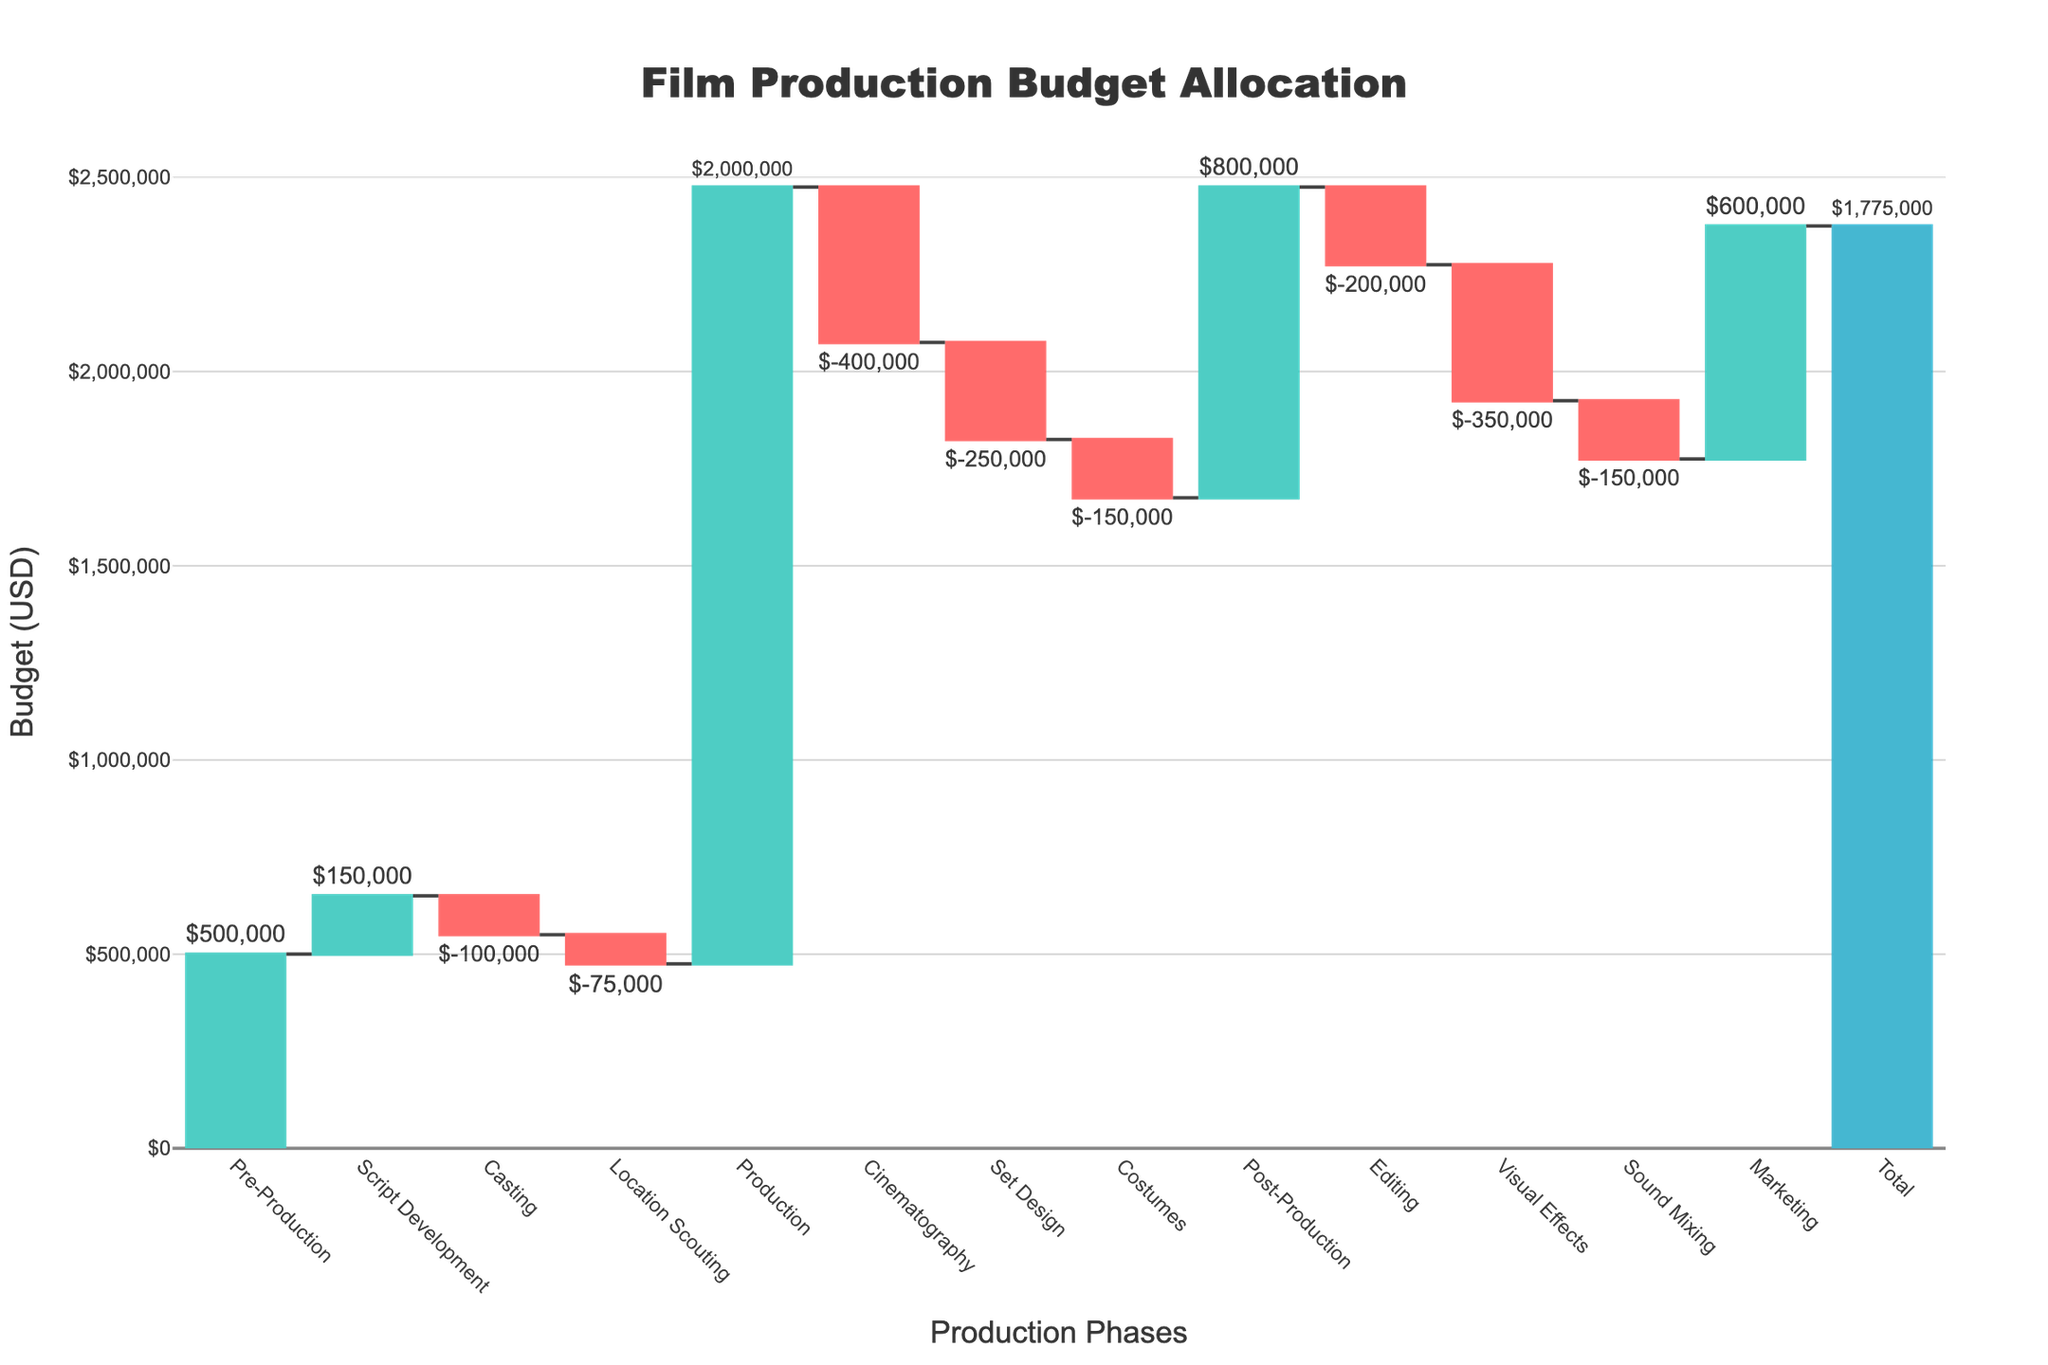How much budget is allocated for Script Development? Look at the bar labeled "Script Development" on the waterfall chart, and note the value mentioned next to it.
Answer: $150,000 Which phase had the highest decrease in budget? Identify the phases with negative values and determine which one has the largest absolute value. "Cinematography" decreases by $400,000, which is the highest.
Answer: Cinematography What is the total budget allocated during the Production phase? Check the label "Production" on the chart, which shows the complete budget for this phase.
Answer: $2,000,000 How does the budget allocation for Marketing compare to Post-Production? Compare the value of "Marketing" ($600,000) with the value of "Post-Production" ($800,000), noting that Post-Production includes three sub-categories.
Answer: Lower What is the cumulative budget after the Pre-Production phase? The cumulative budget after Pre-Production is simply the value of "Pre-Production" since it is the first phase.
Answer: $500,000 What is the budget difference between Casting and Location Scouting? Subtract the value of "Location Scouting" (−$75,000) from "Casting" (−$100,000): −$100,000 - (−$75,000) = −$25,000.
Answer: −$25,000 Which two phases contribute the most to the overall budget increase? Identify the top two phases with the highest positive values: "Production" at $2,000,000 and "Post-Production" at $800,000.
Answer: Production and Post-Production What’s the net impact of the Post-Production phase on the budget? Sum up the values within the Post-Production phase. Editing (−$200,000), Visual Effects (−$350,000), and Sound Mixing (−$150,000): −$200,000 - $350,000 - $150,000 = −$700,000.
Answer: −$700,000 If the budget for Set Design was doubled, what would be the new cumulative total? Add the difference from doubling Set Design's value (2 × -$250,000 − -$250,000 = -$250,000) to the total: $1,775,000 + -$250,000 = $1,525,000.
Answer: $1,525,000 What percentage of the total budget is allocated to Marketing? Divide the Marketing budget by the total and multiply by 100 to find the percentage: ($600,000 / $1,775,000) × 100 ≈ 33.8%.
Answer: 33.8% 